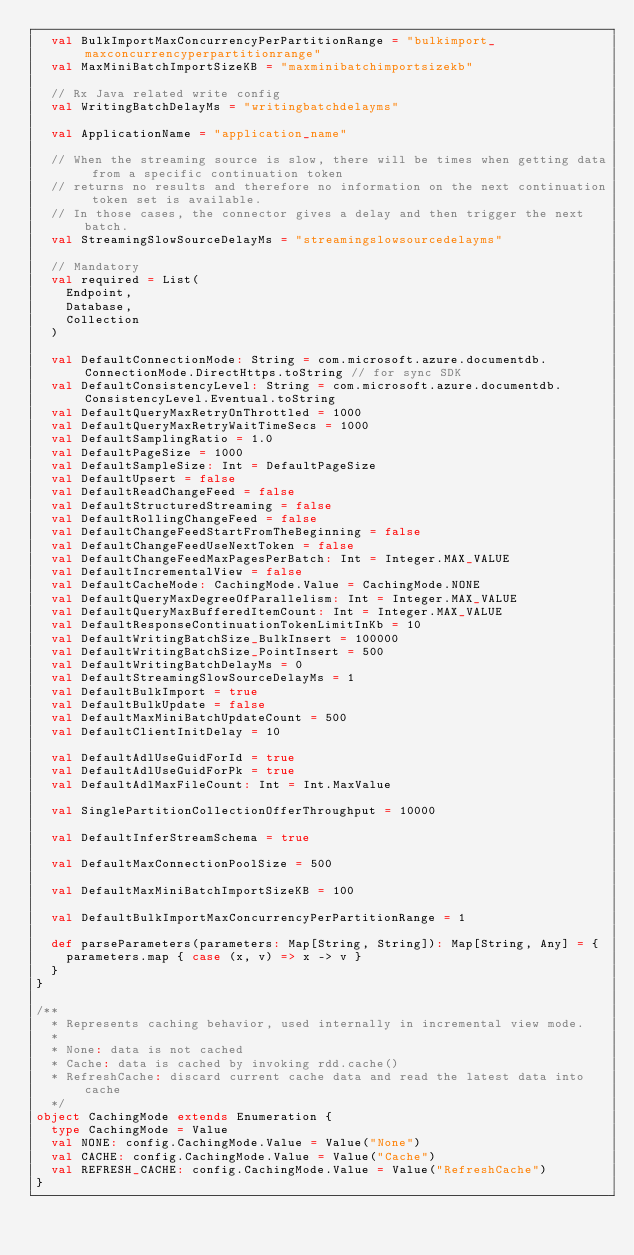<code> <loc_0><loc_0><loc_500><loc_500><_Scala_>  val BulkImportMaxConcurrencyPerPartitionRange = "bulkimport_maxconcurrencyperpartitionrange"
  val MaxMiniBatchImportSizeKB = "maxminibatchimportsizekb"

  // Rx Java related write config
  val WritingBatchDelayMs = "writingbatchdelayms"

  val ApplicationName = "application_name"

  // When the streaming source is slow, there will be times when getting data from a specific continuation token
  // returns no results and therefore no information on the next continuation token set is available.
  // In those cases, the connector gives a delay and then trigger the next batch.
  val StreamingSlowSourceDelayMs = "streamingslowsourcedelayms"

  // Mandatory
  val required = List(
    Endpoint,
    Database,
    Collection
  )

  val DefaultConnectionMode: String = com.microsoft.azure.documentdb.ConnectionMode.DirectHttps.toString // for sync SDK
  val DefaultConsistencyLevel: String = com.microsoft.azure.documentdb.ConsistencyLevel.Eventual.toString
  val DefaultQueryMaxRetryOnThrottled = 1000
  val DefaultQueryMaxRetryWaitTimeSecs = 1000
  val DefaultSamplingRatio = 1.0
  val DefaultPageSize = 1000
  val DefaultSampleSize: Int = DefaultPageSize
  val DefaultUpsert = false
  val DefaultReadChangeFeed = false
  val DefaultStructuredStreaming = false
  val DefaultRollingChangeFeed = false
  val DefaultChangeFeedStartFromTheBeginning = false
  val DefaultChangeFeedUseNextToken = false
  val DefaultChangeFeedMaxPagesPerBatch: Int = Integer.MAX_VALUE
  val DefaultIncrementalView = false
  val DefaultCacheMode: CachingMode.Value = CachingMode.NONE
  val DefaultQueryMaxDegreeOfParallelism: Int = Integer.MAX_VALUE
  val DefaultQueryMaxBufferedItemCount: Int = Integer.MAX_VALUE
  val DefaultResponseContinuationTokenLimitInKb = 10
  val DefaultWritingBatchSize_BulkInsert = 100000
  val DefaultWritingBatchSize_PointInsert = 500
  val DefaultWritingBatchDelayMs = 0
  val DefaultStreamingSlowSourceDelayMs = 1
  val DefaultBulkImport = true
  val DefaultBulkUpdate = false
  val DefaultMaxMiniBatchUpdateCount = 500
  val DefaultClientInitDelay = 10

  val DefaultAdlUseGuidForId = true
  val DefaultAdlUseGuidForPk = true
  val DefaultAdlMaxFileCount: Int = Int.MaxValue

  val SinglePartitionCollectionOfferThroughput = 10000

  val DefaultInferStreamSchema = true

  val DefaultMaxConnectionPoolSize = 500

  val DefaultMaxMiniBatchImportSizeKB = 100

  val DefaultBulkImportMaxConcurrencyPerPartitionRange = 1

  def parseParameters(parameters: Map[String, String]): Map[String, Any] = {
    parameters.map { case (x, v) => x -> v }
  }
}

/**
  * Represents caching behavior, used internally in incremental view mode.
  *
  * None: data is not cached
  * Cache: data is cached by invoking rdd.cache()
  * RefreshCache: discard current cache data and read the latest data into cache
  */
object CachingMode extends Enumeration {
  type CachingMode = Value
  val NONE: config.CachingMode.Value = Value("None")
  val CACHE: config.CachingMode.Value = Value("Cache")
  val REFRESH_CACHE: config.CachingMode.Value = Value("RefreshCache")
}
</code> 